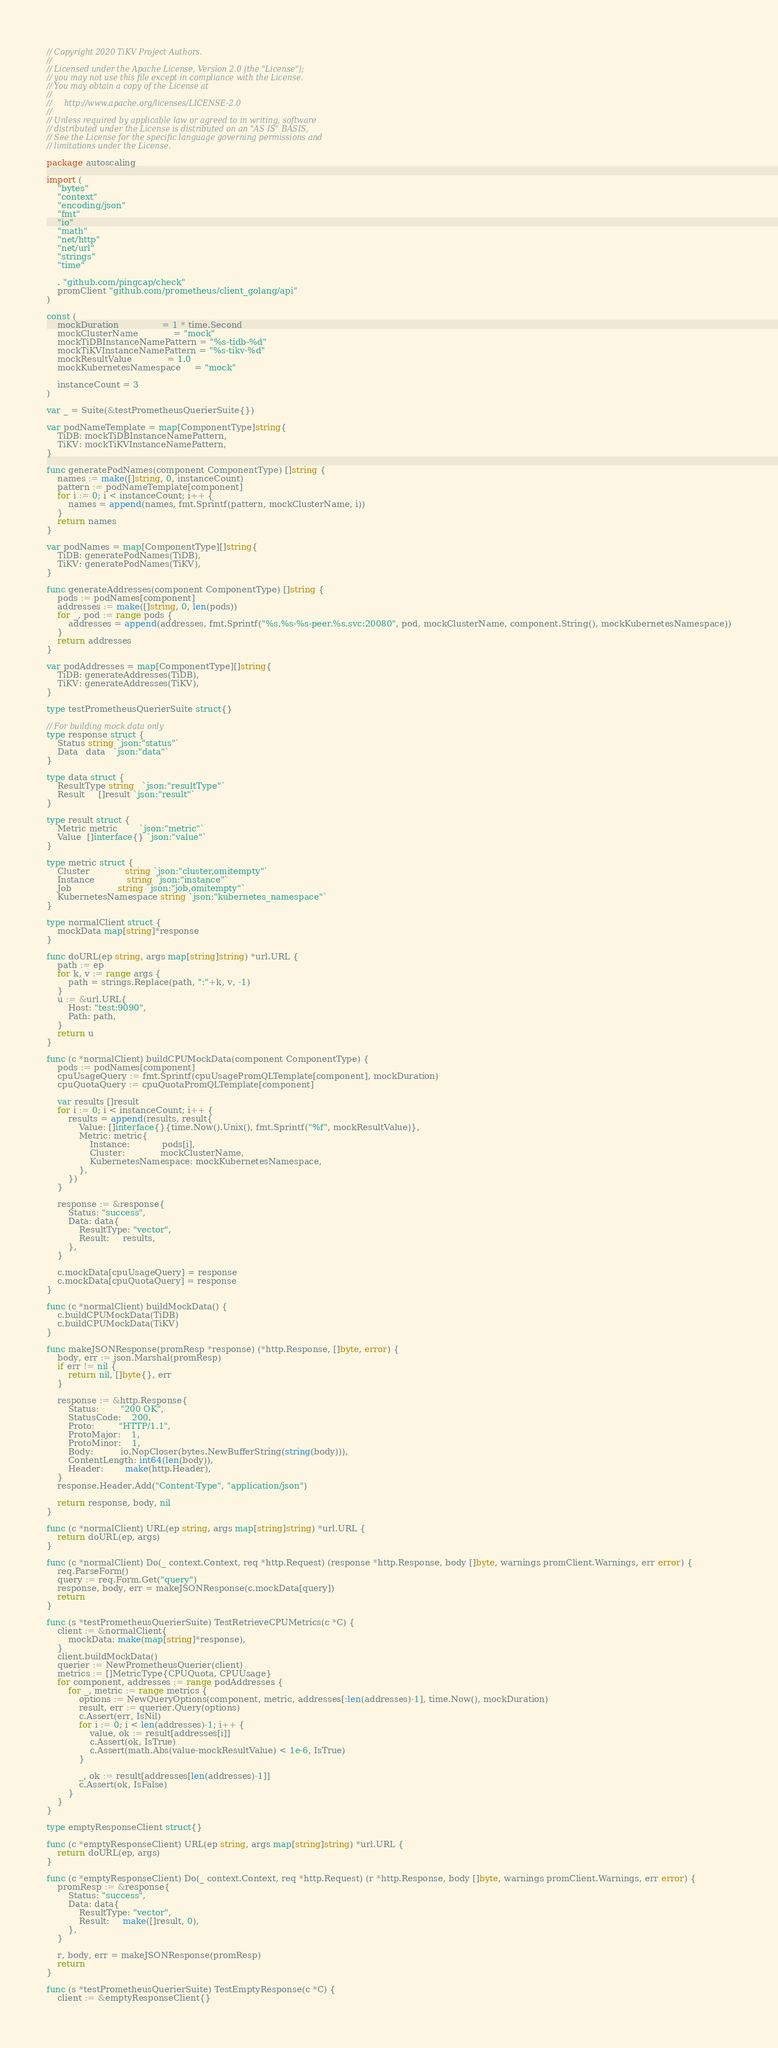Convert code to text. <code><loc_0><loc_0><loc_500><loc_500><_Go_>// Copyright 2020 TiKV Project Authors.
//
// Licensed under the Apache License, Version 2.0 (the "License");
// you may not use this file except in compliance with the License.
// You may obtain a copy of the License at
//
//     http://www.apache.org/licenses/LICENSE-2.0
//
// Unless required by applicable law or agreed to in writing, software
// distributed under the License is distributed on an "AS IS" BASIS,
// See the License for the specific language governing permissions and
// limitations under the License.

package autoscaling

import (
	"bytes"
	"context"
	"encoding/json"
	"fmt"
	"io"
	"math"
	"net/http"
	"net/url"
	"strings"
	"time"

	. "github.com/pingcap/check"
	promClient "github.com/prometheus/client_golang/api"
)

const (
	mockDuration                = 1 * time.Second
	mockClusterName             = "mock"
	mockTiDBInstanceNamePattern = "%s-tidb-%d"
	mockTiKVInstanceNamePattern = "%s-tikv-%d"
	mockResultValue             = 1.0
	mockKubernetesNamespace     = "mock"

	instanceCount = 3
)

var _ = Suite(&testPrometheusQuerierSuite{})

var podNameTemplate = map[ComponentType]string{
	TiDB: mockTiDBInstanceNamePattern,
	TiKV: mockTiKVInstanceNamePattern,
}

func generatePodNames(component ComponentType) []string {
	names := make([]string, 0, instanceCount)
	pattern := podNameTemplate[component]
	for i := 0; i < instanceCount; i++ {
		names = append(names, fmt.Sprintf(pattern, mockClusterName, i))
	}
	return names
}

var podNames = map[ComponentType][]string{
	TiDB: generatePodNames(TiDB),
	TiKV: generatePodNames(TiKV),
}

func generateAddresses(component ComponentType) []string {
	pods := podNames[component]
	addresses := make([]string, 0, len(pods))
	for _, pod := range pods {
		addresses = append(addresses, fmt.Sprintf("%s.%s-%s-peer.%s.svc:20080", pod, mockClusterName, component.String(), mockKubernetesNamespace))
	}
	return addresses
}

var podAddresses = map[ComponentType][]string{
	TiDB: generateAddresses(TiDB),
	TiKV: generateAddresses(TiKV),
}

type testPrometheusQuerierSuite struct{}

// For building mock data only
type response struct {
	Status string `json:"status"`
	Data   data   `json:"data"`
}

type data struct {
	ResultType string   `json:"resultType"`
	Result     []result `json:"result"`
}

type result struct {
	Metric metric        `json:"metric"`
	Value  []interface{} `json:"value"`
}

type metric struct {
	Cluster             string `json:"cluster,omitempty"`
	Instance            string `json:"instance"`
	Job                 string `json:"job,omitempty"`
	KubernetesNamespace string `json:"kubernetes_namespace"`
}

type normalClient struct {
	mockData map[string]*response
}

func doURL(ep string, args map[string]string) *url.URL {
	path := ep
	for k, v := range args {
		path = strings.Replace(path, ":"+k, v, -1)
	}
	u := &url.URL{
		Host: "test:9090",
		Path: path,
	}
	return u
}

func (c *normalClient) buildCPUMockData(component ComponentType) {
	pods := podNames[component]
	cpuUsageQuery := fmt.Sprintf(cpuUsagePromQLTemplate[component], mockDuration)
	cpuQuotaQuery := cpuQuotaPromQLTemplate[component]

	var results []result
	for i := 0; i < instanceCount; i++ {
		results = append(results, result{
			Value: []interface{}{time.Now().Unix(), fmt.Sprintf("%f", mockResultValue)},
			Metric: metric{
				Instance:            pods[i],
				Cluster:             mockClusterName,
				KubernetesNamespace: mockKubernetesNamespace,
			},
		})
	}

	response := &response{
		Status: "success",
		Data: data{
			ResultType: "vector",
			Result:     results,
		},
	}

	c.mockData[cpuUsageQuery] = response
	c.mockData[cpuQuotaQuery] = response
}

func (c *normalClient) buildMockData() {
	c.buildCPUMockData(TiDB)
	c.buildCPUMockData(TiKV)
}

func makeJSONResponse(promResp *response) (*http.Response, []byte, error) {
	body, err := json.Marshal(promResp)
	if err != nil {
		return nil, []byte{}, err
	}

	response := &http.Response{
		Status:        "200 OK",
		StatusCode:    200,
		Proto:         "HTTP/1.1",
		ProtoMajor:    1,
		ProtoMinor:    1,
		Body:          io.NopCloser(bytes.NewBufferString(string(body))),
		ContentLength: int64(len(body)),
		Header:        make(http.Header),
	}
	response.Header.Add("Content-Type", "application/json")

	return response, body, nil
}

func (c *normalClient) URL(ep string, args map[string]string) *url.URL {
	return doURL(ep, args)
}

func (c *normalClient) Do(_ context.Context, req *http.Request) (response *http.Response, body []byte, warnings promClient.Warnings, err error) {
	req.ParseForm()
	query := req.Form.Get("query")
	response, body, err = makeJSONResponse(c.mockData[query])
	return
}

func (s *testPrometheusQuerierSuite) TestRetrieveCPUMetrics(c *C) {
	client := &normalClient{
		mockData: make(map[string]*response),
	}
	client.buildMockData()
	querier := NewPrometheusQuerier(client)
	metrics := []MetricType{CPUQuota, CPUUsage}
	for component, addresses := range podAddresses {
		for _, metric := range metrics {
			options := NewQueryOptions(component, metric, addresses[:len(addresses)-1], time.Now(), mockDuration)
			result, err := querier.Query(options)
			c.Assert(err, IsNil)
			for i := 0; i < len(addresses)-1; i++ {
				value, ok := result[addresses[i]]
				c.Assert(ok, IsTrue)
				c.Assert(math.Abs(value-mockResultValue) < 1e-6, IsTrue)
			}

			_, ok := result[addresses[len(addresses)-1]]
			c.Assert(ok, IsFalse)
		}
	}
}

type emptyResponseClient struct{}

func (c *emptyResponseClient) URL(ep string, args map[string]string) *url.URL {
	return doURL(ep, args)
}

func (c *emptyResponseClient) Do(_ context.Context, req *http.Request) (r *http.Response, body []byte, warnings promClient.Warnings, err error) {
	promResp := &response{
		Status: "success",
		Data: data{
			ResultType: "vector",
			Result:     make([]result, 0),
		},
	}

	r, body, err = makeJSONResponse(promResp)
	return
}

func (s *testPrometheusQuerierSuite) TestEmptyResponse(c *C) {
	client := &emptyResponseClient{}</code> 